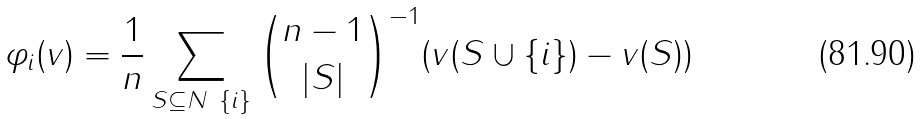<formula> <loc_0><loc_0><loc_500><loc_500>\varphi _ { i } ( v ) = { \frac { 1 } { n } } \sum _ { S \subseteq N \ \{ i \} } { \binom { n - 1 } { | S | } } ^ { - 1 } ( v ( S \cup \{ i \} ) - v ( S ) )</formula> 